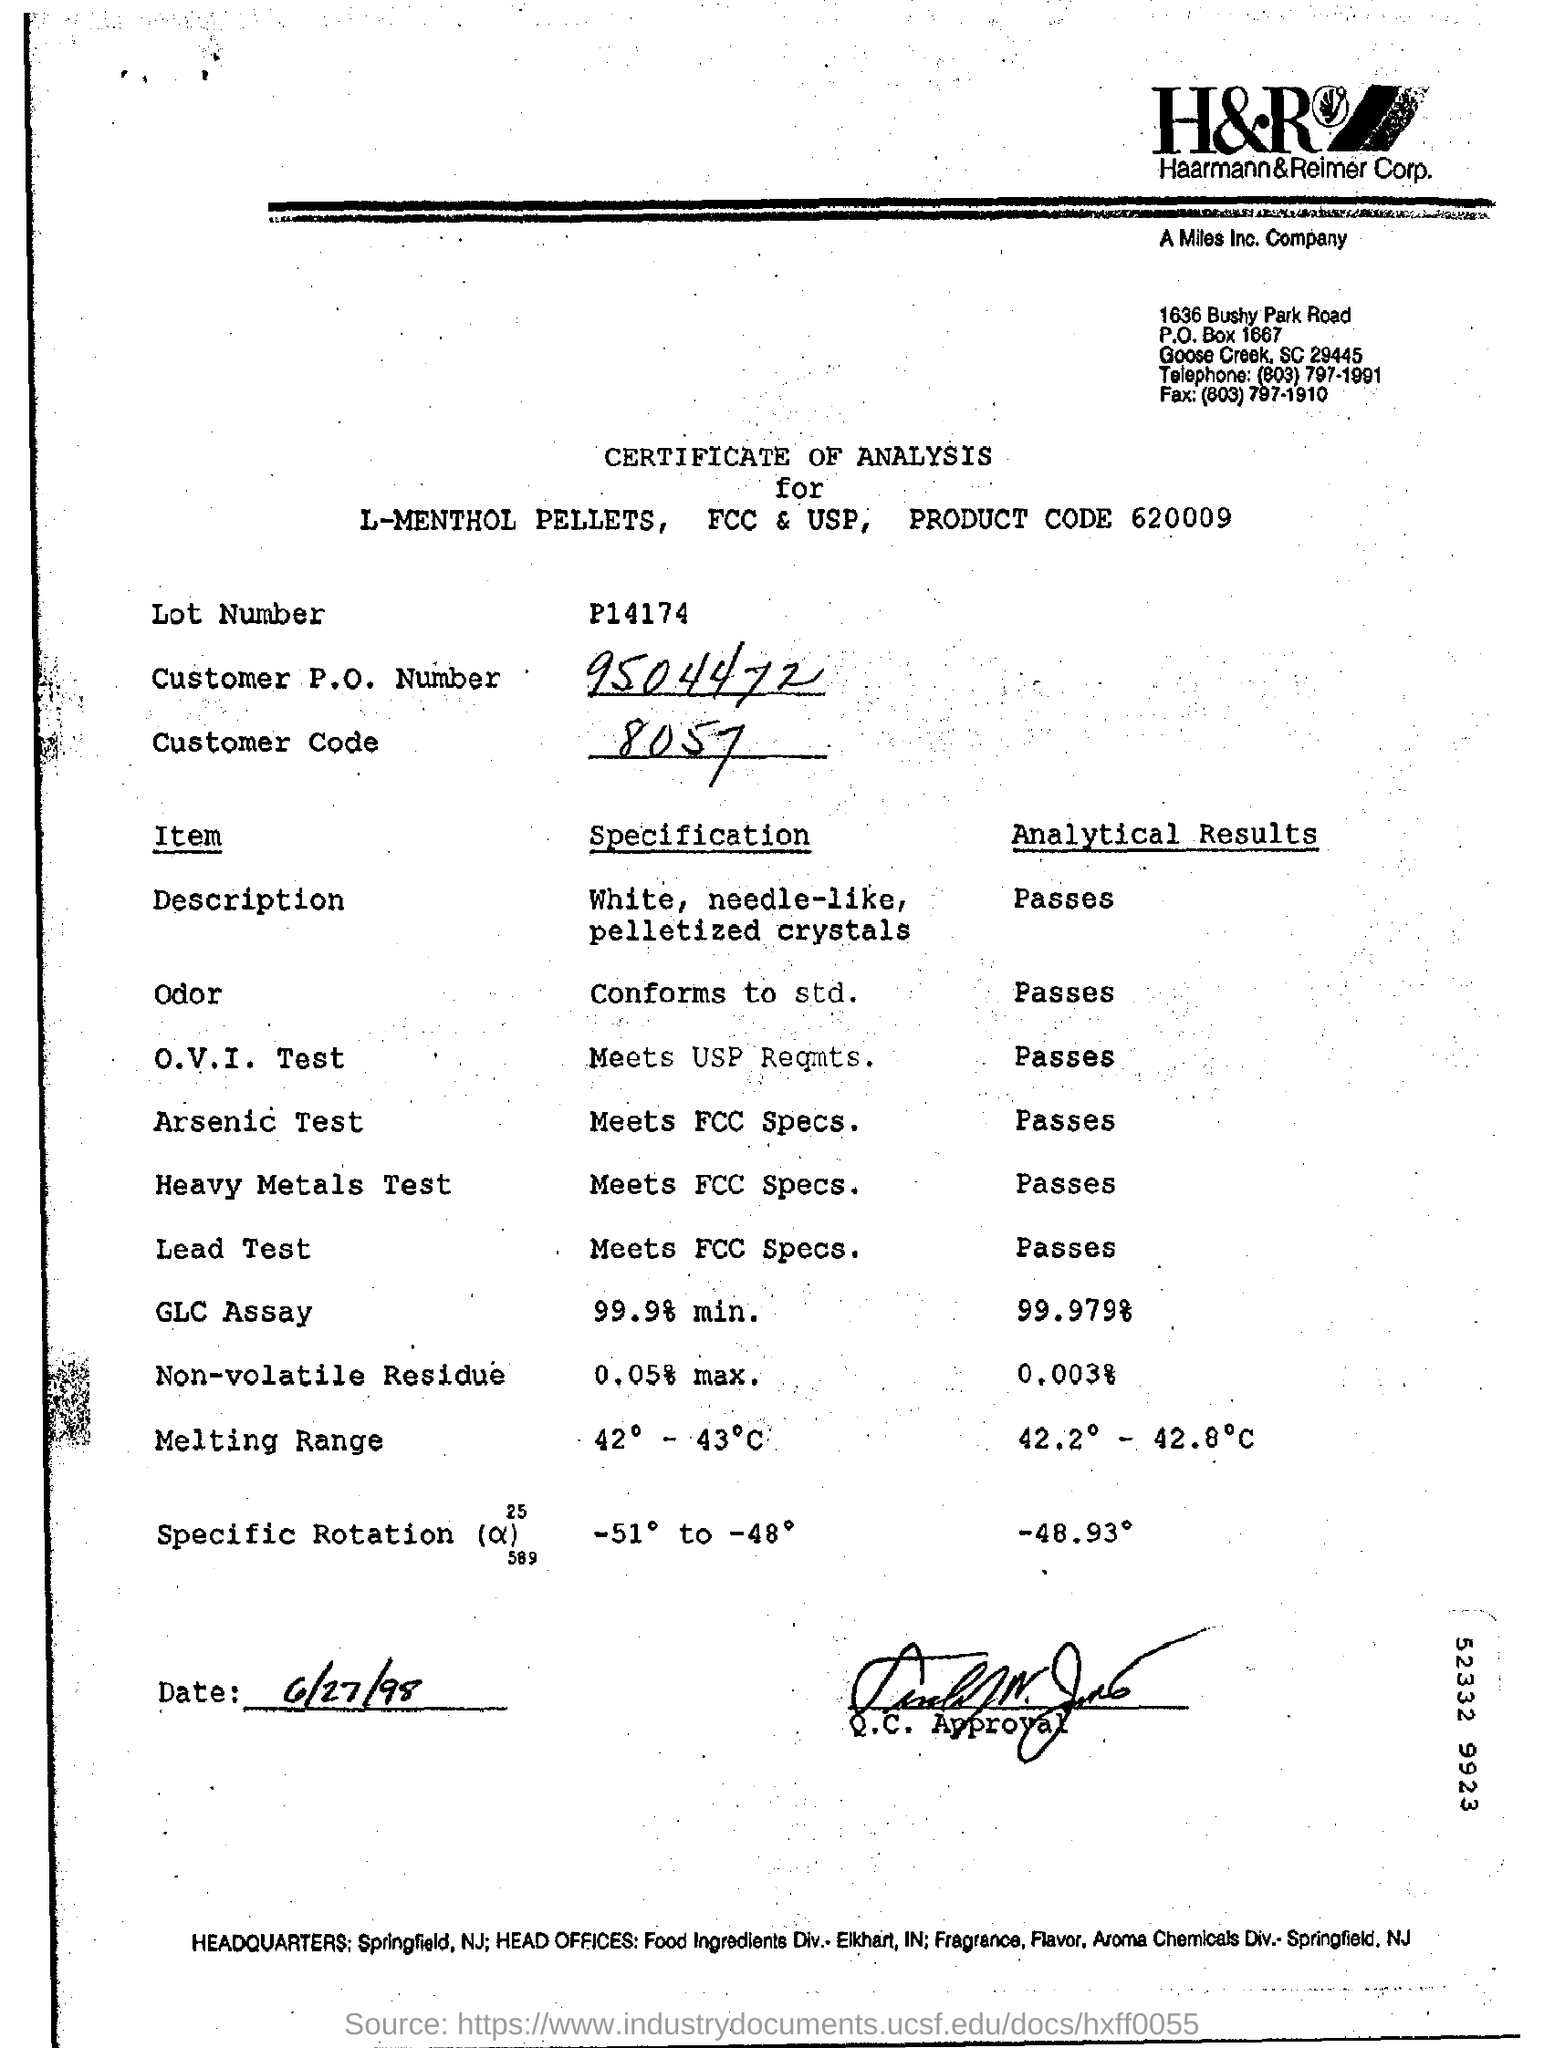Identify some key points in this picture. The date is June 27, 1998. Customer code 8057 refers to a unique identifier assigned to a customer for purposes of tracking and managing their account. What is the customer P.O. number? It is 9504472... 